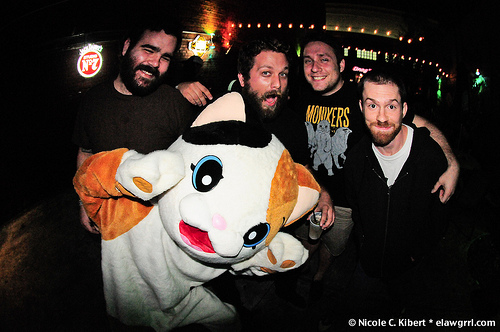<image>
Is the man on the cat? Yes. Looking at the image, I can see the man is positioned on top of the cat, with the cat providing support. 